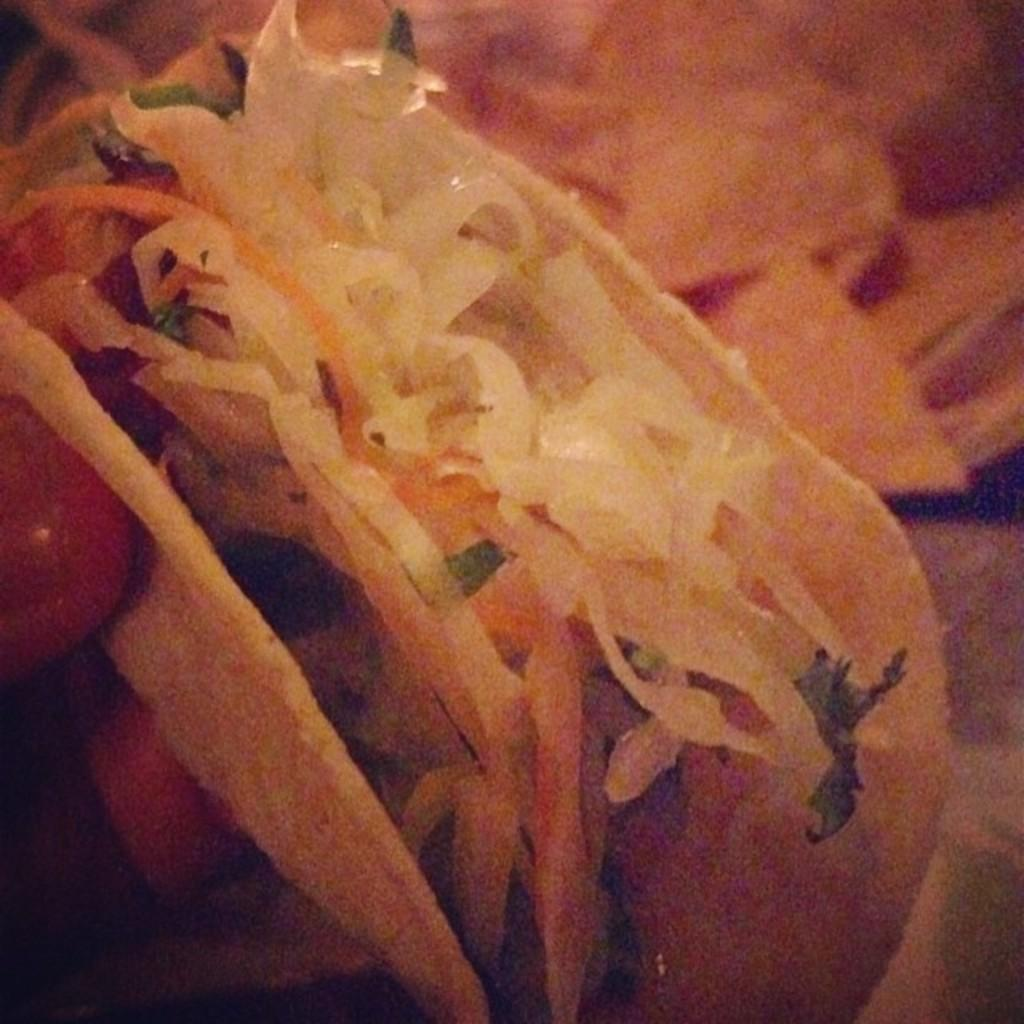What is the person's hand holding in the image? The person's hand is holding a food item in the image. Can you describe the colors of the food item? The food item has cream, brown, and green colors. How would you describe the background of the image? The background of the image is blurry. What color is the background of the image? The background color is brown. How many spots can be seen on the paper in the image? There is no paper present in the image, so it is not possible to determine the number of spots on it. 